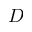Convert formula to latex. <formula><loc_0><loc_0><loc_500><loc_500>D</formula> 